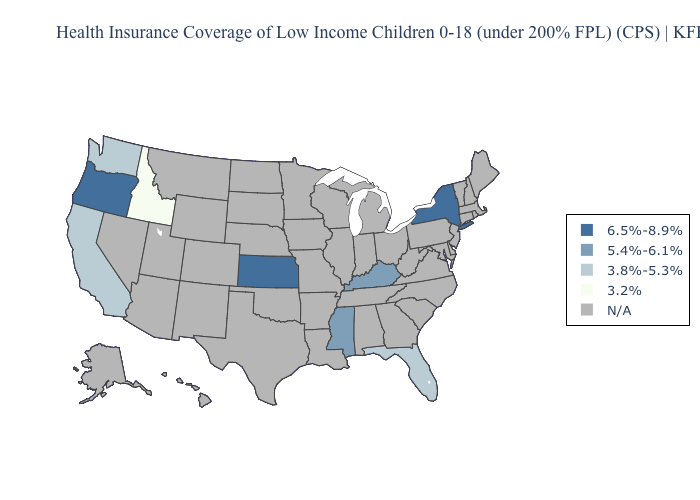Which states have the lowest value in the USA?
Be succinct. Idaho. Which states have the lowest value in the USA?
Write a very short answer. Idaho. What is the value of South Dakota?
Concise answer only. N/A. What is the lowest value in the South?
Be succinct. 3.8%-5.3%. Does Kentucky have the highest value in the South?
Give a very brief answer. Yes. Does Washington have the highest value in the USA?
Write a very short answer. No. What is the value of North Carolina?
Be succinct. N/A. Is the legend a continuous bar?
Quick response, please. No. What is the value of Hawaii?
Write a very short answer. N/A. Which states have the lowest value in the West?
Write a very short answer. Idaho. Name the states that have a value in the range N/A?
Quick response, please. Alabama, Alaska, Arizona, Arkansas, Colorado, Connecticut, Delaware, Georgia, Hawaii, Illinois, Indiana, Iowa, Louisiana, Maine, Maryland, Massachusetts, Michigan, Minnesota, Missouri, Montana, Nebraska, Nevada, New Hampshire, New Jersey, New Mexico, North Carolina, North Dakota, Ohio, Oklahoma, Pennsylvania, Rhode Island, South Carolina, South Dakota, Tennessee, Texas, Utah, Vermont, Virginia, West Virginia, Wisconsin, Wyoming. What is the lowest value in the MidWest?
Answer briefly. 6.5%-8.9%. Name the states that have a value in the range 3.8%-5.3%?
Quick response, please. California, Florida, Washington. Which states have the lowest value in the MidWest?
Keep it brief. Kansas. 